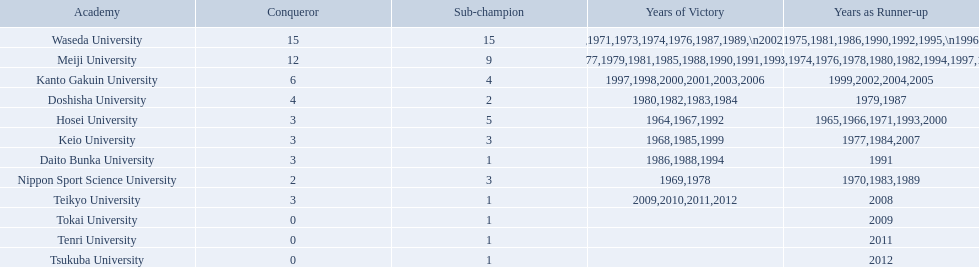What are all of the universities? Waseda University, Meiji University, Kanto Gakuin University, Doshisha University, Hosei University, Keio University, Daito Bunka University, Nippon Sport Science University, Teikyo University, Tokai University, Tenri University, Tsukuba University. And their scores? 15, 12, 6, 4, 3, 3, 3, 2, 3, 0, 0, 0. Which university scored won the most? Waseda University. 